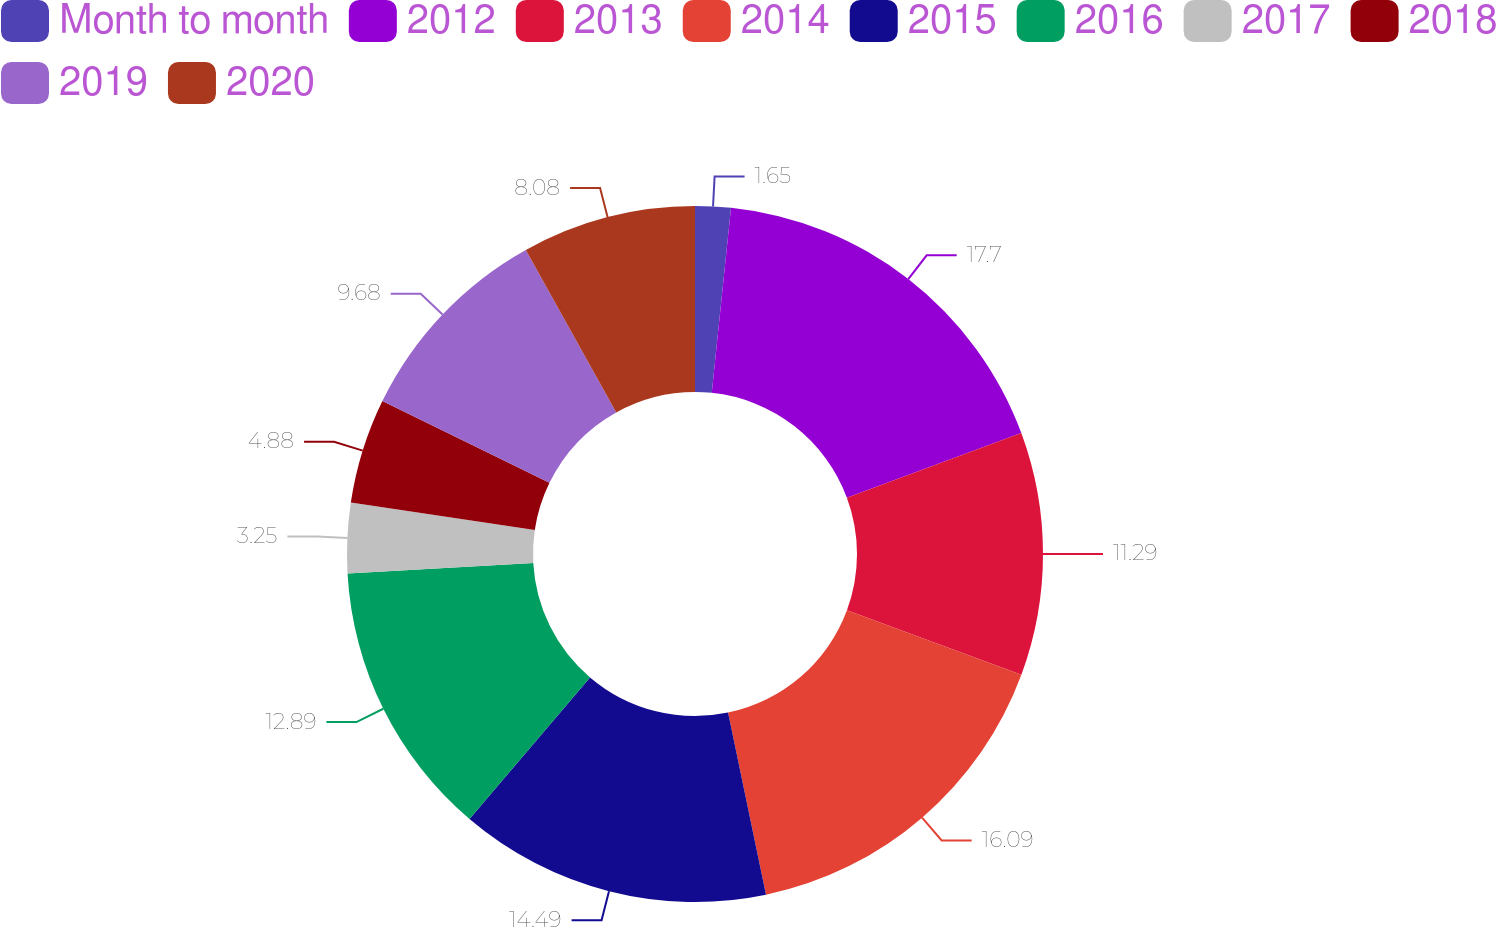Convert chart. <chart><loc_0><loc_0><loc_500><loc_500><pie_chart><fcel>Month to month<fcel>2012<fcel>2013<fcel>2014<fcel>2015<fcel>2016<fcel>2017<fcel>2018<fcel>2019<fcel>2020<nl><fcel>1.65%<fcel>17.7%<fcel>11.29%<fcel>16.09%<fcel>14.49%<fcel>12.89%<fcel>3.25%<fcel>4.88%<fcel>9.68%<fcel>8.08%<nl></chart> 